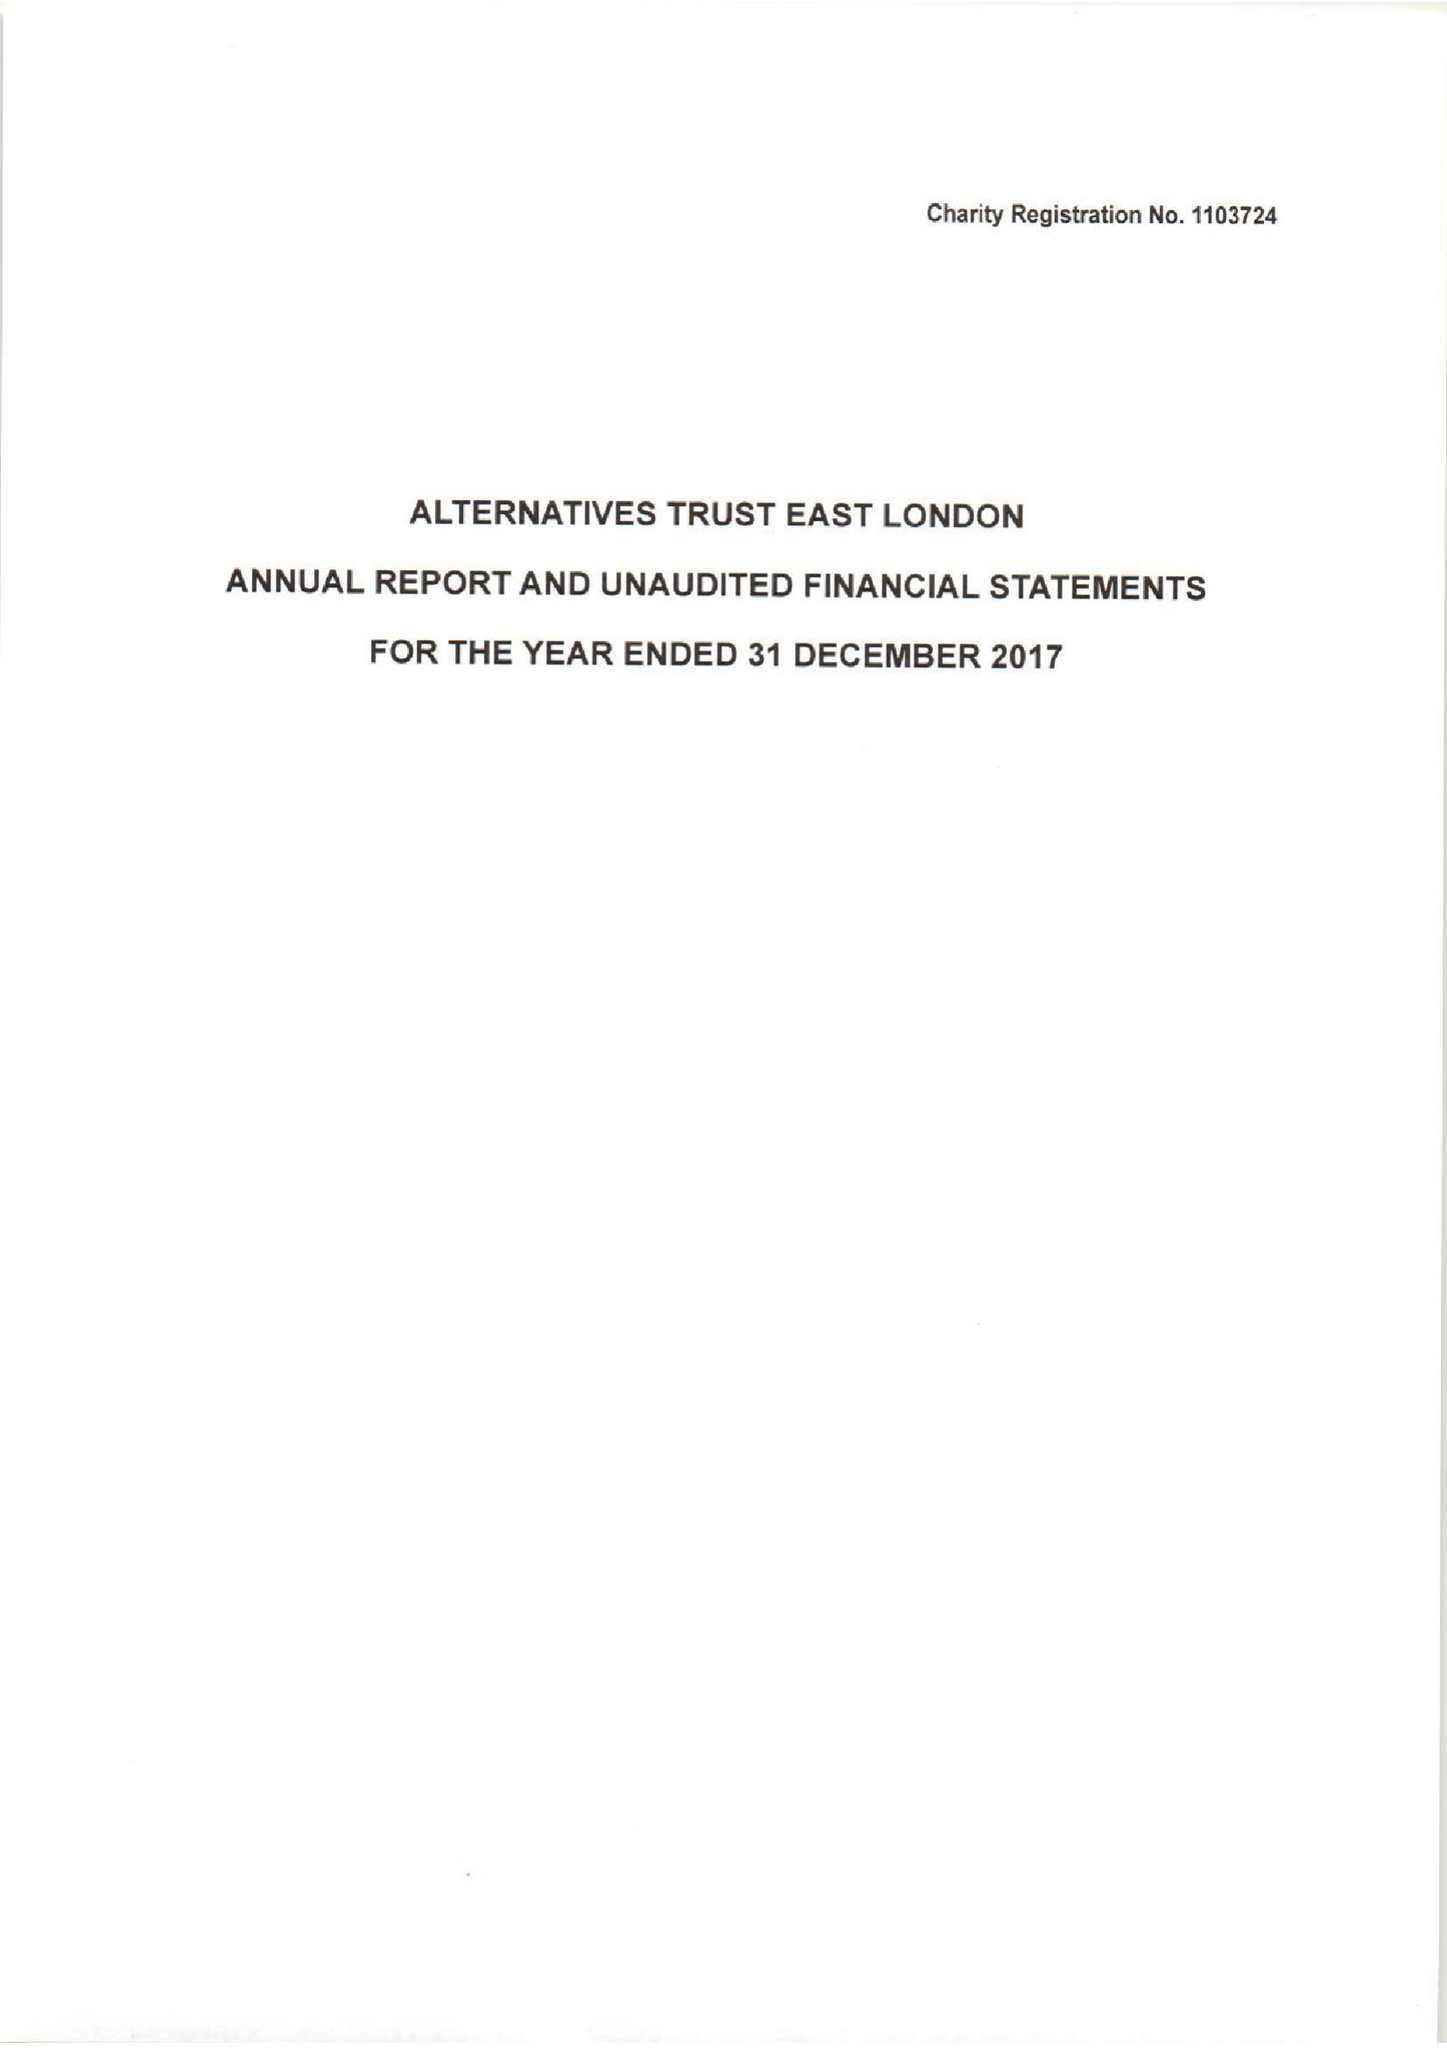What is the value for the spending_annually_in_british_pounds?
Answer the question using a single word or phrase. 173545.00 